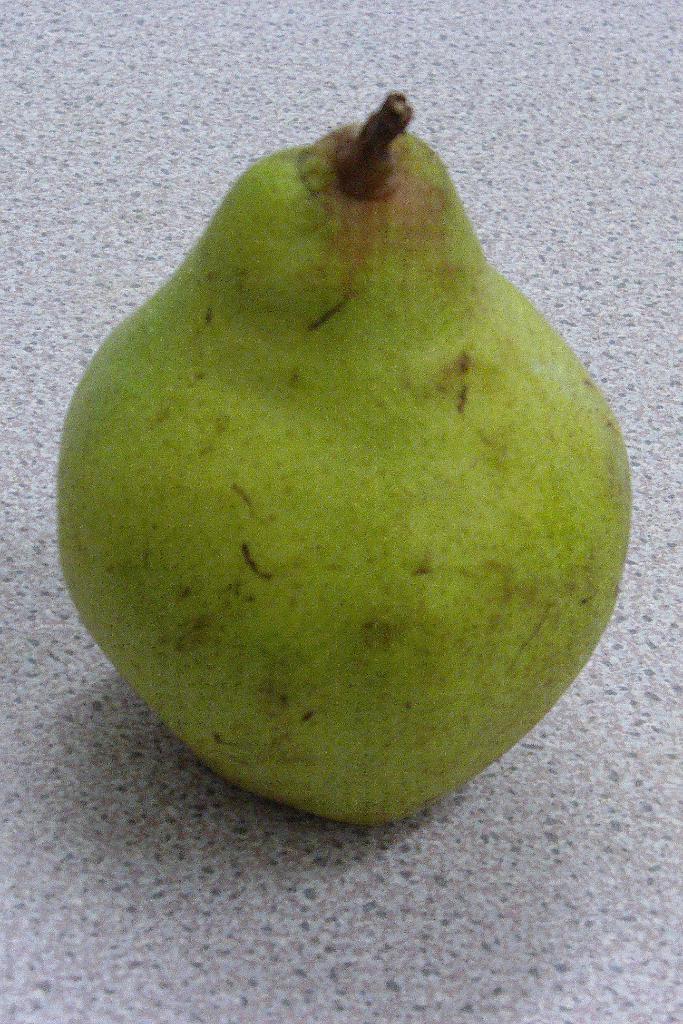Please provide a concise description of this image. In this picture we can observe green color fruit placed on the floor. The floor is in grey color. 